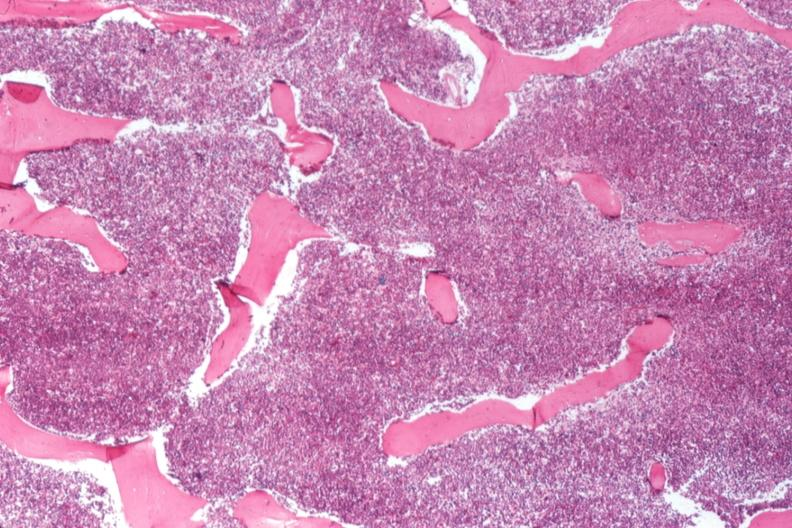s chronic myelogenous leukemia present?
Answer the question using a single word or phrase. Yes 